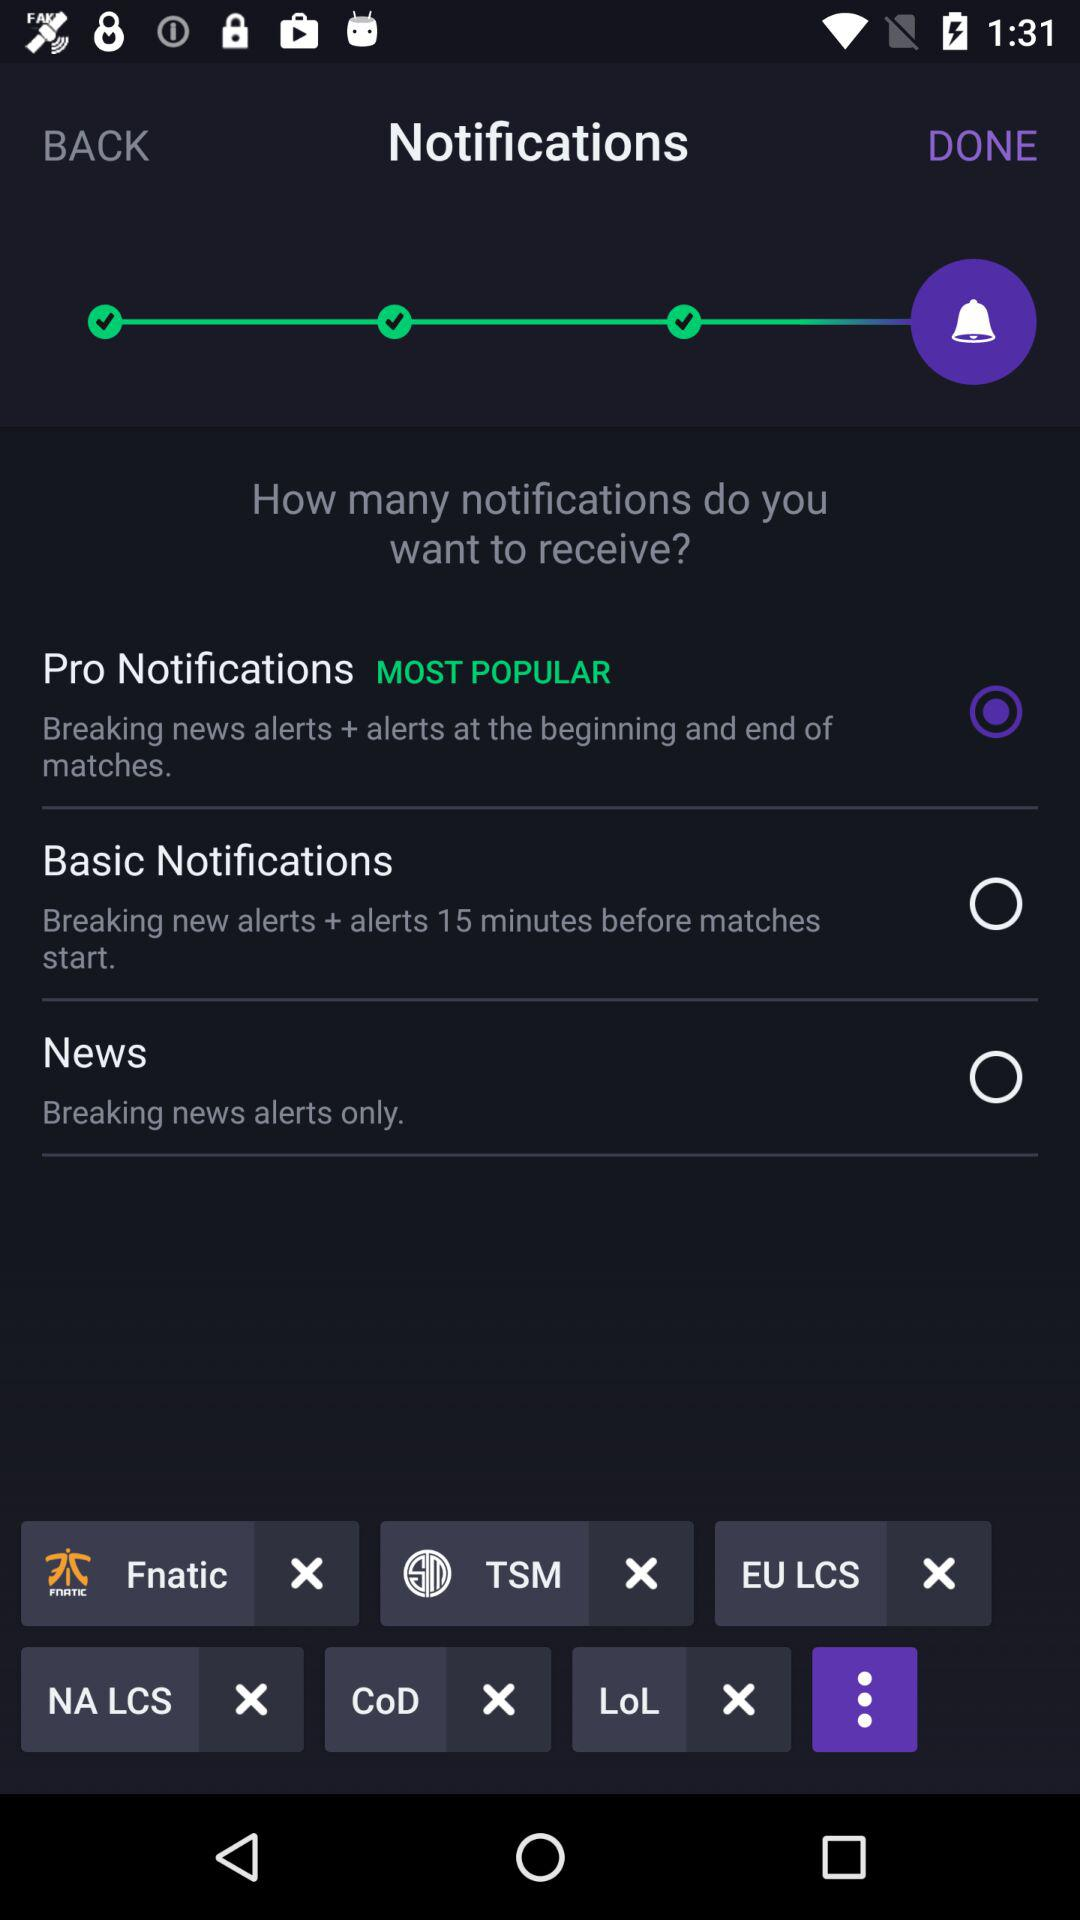Which is the most popular notification? The most popular notification is "Pro Notifications". 